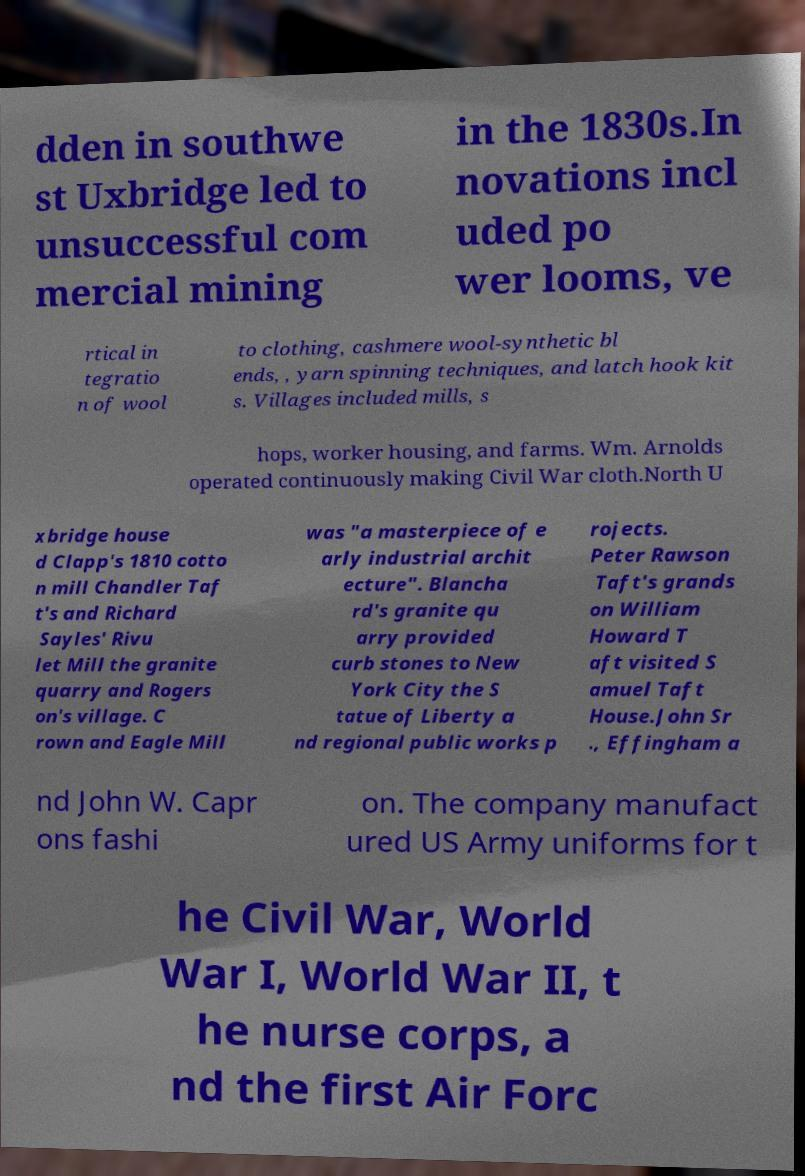What messages or text are displayed in this image? I need them in a readable, typed format. dden in southwe st Uxbridge led to unsuccessful com mercial mining in the 1830s.In novations incl uded po wer looms, ve rtical in tegratio n of wool to clothing, cashmere wool-synthetic bl ends, , yarn spinning techniques, and latch hook kit s. Villages included mills, s hops, worker housing, and farms. Wm. Arnolds operated continuously making Civil War cloth.North U xbridge house d Clapp's 1810 cotto n mill Chandler Taf t's and Richard Sayles' Rivu let Mill the granite quarry and Rogers on's village. C rown and Eagle Mill was "a masterpiece of e arly industrial archit ecture". Blancha rd's granite qu arry provided curb stones to New York City the S tatue of Liberty a nd regional public works p rojects. Peter Rawson Taft's grands on William Howard T aft visited S amuel Taft House.John Sr ., Effingham a nd John W. Capr ons fashi on. The company manufact ured US Army uniforms for t he Civil War, World War I, World War II, t he nurse corps, a nd the first Air Forc 